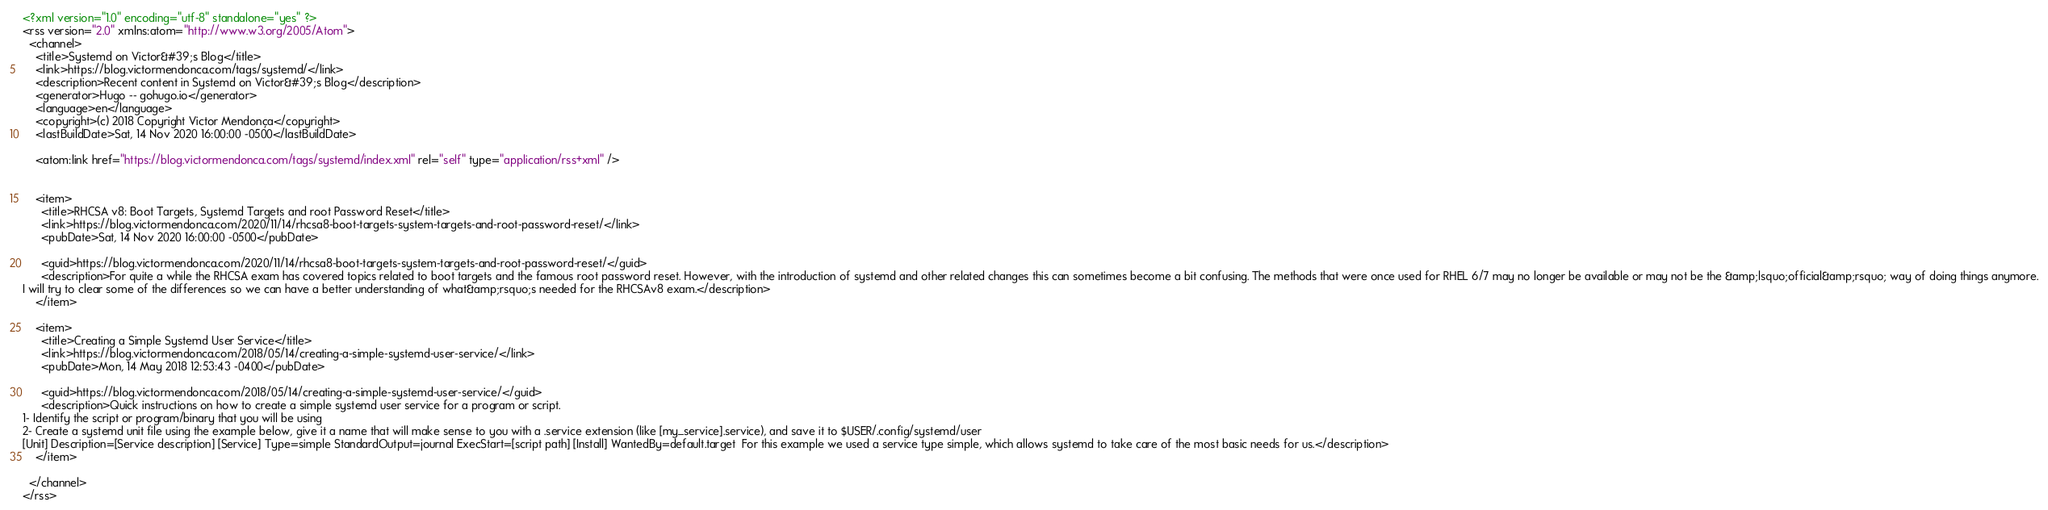<code> <loc_0><loc_0><loc_500><loc_500><_XML_><?xml version="1.0" encoding="utf-8" standalone="yes" ?>
<rss version="2.0" xmlns:atom="http://www.w3.org/2005/Atom">
  <channel>
    <title>Systemd on Victor&#39;s Blog</title>
    <link>https://blog.victormendonca.com/tags/systemd/</link>
    <description>Recent content in Systemd on Victor&#39;s Blog</description>
    <generator>Hugo -- gohugo.io</generator>
    <language>en</language>
    <copyright>(c) 2018 Copyright Victor Mendonça</copyright>
    <lastBuildDate>Sat, 14 Nov 2020 16:00:00 -0500</lastBuildDate>
    
	<atom:link href="https://blog.victormendonca.com/tags/systemd/index.xml" rel="self" type="application/rss+xml" />
    
    
    <item>
      <title>RHCSA v8: Boot Targets, Systemd Targets and root Password Reset</title>
      <link>https://blog.victormendonca.com/2020/11/14/rhcsa8-boot-targets-system-targets-and-root-password-reset/</link>
      <pubDate>Sat, 14 Nov 2020 16:00:00 -0500</pubDate>
      
      <guid>https://blog.victormendonca.com/2020/11/14/rhcsa8-boot-targets-system-targets-and-root-password-reset/</guid>
      <description>For quite a while the RHCSA exam has covered topics related to boot targets and the famous root password reset. However, with the introduction of systemd and other related changes this can sometimes become a bit confusing. The methods that were once used for RHEL 6/7 may no longer be available or may not be the &amp;lsquo;official&amp;rsquo; way of doing things anymore.
I will try to clear some of the differences so we can have a better understanding of what&amp;rsquo;s needed for the RHCSAv8 exam.</description>
    </item>
    
    <item>
      <title>Creating a Simple Systemd User Service</title>
      <link>https://blog.victormendonca.com/2018/05/14/creating-a-simple-systemd-user-service/</link>
      <pubDate>Mon, 14 May 2018 12:53:43 -0400</pubDate>
      
      <guid>https://blog.victormendonca.com/2018/05/14/creating-a-simple-systemd-user-service/</guid>
      <description>Quick instructions on how to create a simple systemd user service for a program or script.
1- Identify the script or program/binary that you will be using
2- Create a systemd unit file using the example below, give it a name that will make sense to you with a .service extension (like [my_service].service), and save it to $USER/.config/systemd/user
[Unit] Description=[Service description] [Service] Type=simple StandardOutput=journal ExecStart=[script path] [Install] WantedBy=default.target  For this example we used a service type simple, which allows systemd to take care of the most basic needs for us.</description>
    </item>
    
  </channel>
</rss></code> 